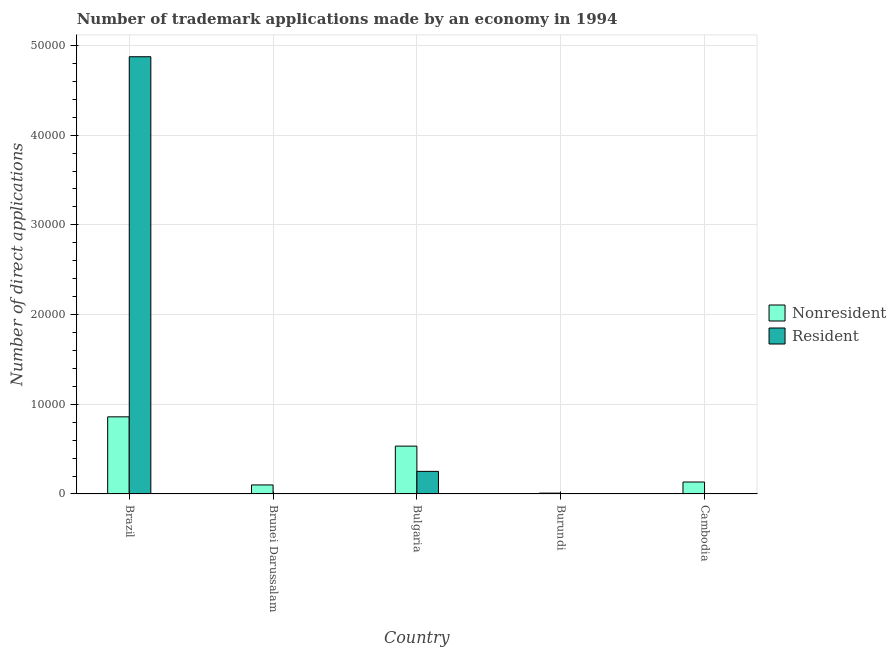What is the label of the 2nd group of bars from the left?
Provide a succinct answer. Brunei Darussalam. In how many cases, is the number of bars for a given country not equal to the number of legend labels?
Make the answer very short. 0. What is the number of trademark applications made by non residents in Brazil?
Offer a terse response. 8599. Across all countries, what is the maximum number of trademark applications made by residents?
Provide a short and direct response. 4.87e+04. Across all countries, what is the minimum number of trademark applications made by non residents?
Your answer should be very brief. 93. In which country was the number of trademark applications made by residents minimum?
Give a very brief answer. Brunei Darussalam. What is the total number of trademark applications made by non residents in the graph?
Offer a very short reply. 1.64e+04. What is the difference between the number of trademark applications made by residents in Brazil and that in Cambodia?
Your answer should be very brief. 4.87e+04. What is the difference between the number of trademark applications made by residents in Cambodia and the number of trademark applications made by non residents in Brazil?
Your response must be concise. -8596. What is the average number of trademark applications made by residents per country?
Your answer should be very brief. 1.03e+04. What is the difference between the number of trademark applications made by non residents and number of trademark applications made by residents in Cambodia?
Offer a terse response. 1331. In how many countries, is the number of trademark applications made by residents greater than 28000 ?
Your response must be concise. 1. What is the ratio of the number of trademark applications made by non residents in Bulgaria to that in Burundi?
Your response must be concise. 57.37. Is the number of trademark applications made by residents in Burundi less than that in Cambodia?
Your response must be concise. No. What is the difference between the highest and the second highest number of trademark applications made by residents?
Your response must be concise. 4.62e+04. What is the difference between the highest and the lowest number of trademark applications made by residents?
Offer a very short reply. 4.87e+04. What does the 1st bar from the left in Brunei Darussalam represents?
Ensure brevity in your answer.  Nonresident. What does the 1st bar from the right in Burundi represents?
Your answer should be very brief. Resident. How many bars are there?
Ensure brevity in your answer.  10. How many countries are there in the graph?
Provide a succinct answer. 5. Are the values on the major ticks of Y-axis written in scientific E-notation?
Offer a terse response. No. Does the graph contain any zero values?
Offer a terse response. No. Does the graph contain grids?
Give a very brief answer. Yes. Where does the legend appear in the graph?
Provide a short and direct response. Center right. How many legend labels are there?
Ensure brevity in your answer.  2. What is the title of the graph?
Keep it short and to the point. Number of trademark applications made by an economy in 1994. Does "Female entrants" appear as one of the legend labels in the graph?
Ensure brevity in your answer.  No. What is the label or title of the Y-axis?
Your answer should be very brief. Number of direct applications. What is the Number of direct applications of Nonresident in Brazil?
Your answer should be very brief. 8599. What is the Number of direct applications in Resident in Brazil?
Give a very brief answer. 4.87e+04. What is the Number of direct applications in Nonresident in Brunei Darussalam?
Your answer should be compact. 1008. What is the Number of direct applications of Resident in Brunei Darussalam?
Ensure brevity in your answer.  3. What is the Number of direct applications of Nonresident in Bulgaria?
Make the answer very short. 5335. What is the Number of direct applications of Resident in Bulgaria?
Your answer should be compact. 2520. What is the Number of direct applications of Nonresident in Burundi?
Provide a succinct answer. 93. What is the Number of direct applications of Nonresident in Cambodia?
Offer a terse response. 1334. Across all countries, what is the maximum Number of direct applications in Nonresident?
Ensure brevity in your answer.  8599. Across all countries, what is the maximum Number of direct applications of Resident?
Provide a succinct answer. 4.87e+04. Across all countries, what is the minimum Number of direct applications of Nonresident?
Provide a short and direct response. 93. Across all countries, what is the minimum Number of direct applications of Resident?
Offer a terse response. 3. What is the total Number of direct applications of Nonresident in the graph?
Your answer should be very brief. 1.64e+04. What is the total Number of direct applications of Resident in the graph?
Ensure brevity in your answer.  5.13e+04. What is the difference between the Number of direct applications in Nonresident in Brazil and that in Brunei Darussalam?
Your answer should be very brief. 7591. What is the difference between the Number of direct applications of Resident in Brazil and that in Brunei Darussalam?
Your response must be concise. 4.87e+04. What is the difference between the Number of direct applications in Nonresident in Brazil and that in Bulgaria?
Make the answer very short. 3264. What is the difference between the Number of direct applications of Resident in Brazil and that in Bulgaria?
Your response must be concise. 4.62e+04. What is the difference between the Number of direct applications in Nonresident in Brazil and that in Burundi?
Your answer should be very brief. 8506. What is the difference between the Number of direct applications in Resident in Brazil and that in Burundi?
Your response must be concise. 4.87e+04. What is the difference between the Number of direct applications of Nonresident in Brazil and that in Cambodia?
Your response must be concise. 7265. What is the difference between the Number of direct applications of Resident in Brazil and that in Cambodia?
Provide a succinct answer. 4.87e+04. What is the difference between the Number of direct applications of Nonresident in Brunei Darussalam and that in Bulgaria?
Your response must be concise. -4327. What is the difference between the Number of direct applications of Resident in Brunei Darussalam and that in Bulgaria?
Make the answer very short. -2517. What is the difference between the Number of direct applications in Nonresident in Brunei Darussalam and that in Burundi?
Provide a succinct answer. 915. What is the difference between the Number of direct applications of Nonresident in Brunei Darussalam and that in Cambodia?
Offer a very short reply. -326. What is the difference between the Number of direct applications of Nonresident in Bulgaria and that in Burundi?
Give a very brief answer. 5242. What is the difference between the Number of direct applications in Resident in Bulgaria and that in Burundi?
Give a very brief answer. 2513. What is the difference between the Number of direct applications of Nonresident in Bulgaria and that in Cambodia?
Give a very brief answer. 4001. What is the difference between the Number of direct applications of Resident in Bulgaria and that in Cambodia?
Your answer should be very brief. 2517. What is the difference between the Number of direct applications in Nonresident in Burundi and that in Cambodia?
Give a very brief answer. -1241. What is the difference between the Number of direct applications in Nonresident in Brazil and the Number of direct applications in Resident in Brunei Darussalam?
Provide a short and direct response. 8596. What is the difference between the Number of direct applications in Nonresident in Brazil and the Number of direct applications in Resident in Bulgaria?
Provide a succinct answer. 6079. What is the difference between the Number of direct applications of Nonresident in Brazil and the Number of direct applications of Resident in Burundi?
Your answer should be compact. 8592. What is the difference between the Number of direct applications in Nonresident in Brazil and the Number of direct applications in Resident in Cambodia?
Your response must be concise. 8596. What is the difference between the Number of direct applications in Nonresident in Brunei Darussalam and the Number of direct applications in Resident in Bulgaria?
Your answer should be very brief. -1512. What is the difference between the Number of direct applications in Nonresident in Brunei Darussalam and the Number of direct applications in Resident in Burundi?
Your response must be concise. 1001. What is the difference between the Number of direct applications of Nonresident in Brunei Darussalam and the Number of direct applications of Resident in Cambodia?
Your response must be concise. 1005. What is the difference between the Number of direct applications of Nonresident in Bulgaria and the Number of direct applications of Resident in Burundi?
Make the answer very short. 5328. What is the difference between the Number of direct applications in Nonresident in Bulgaria and the Number of direct applications in Resident in Cambodia?
Keep it short and to the point. 5332. What is the difference between the Number of direct applications of Nonresident in Burundi and the Number of direct applications of Resident in Cambodia?
Make the answer very short. 90. What is the average Number of direct applications in Nonresident per country?
Provide a succinct answer. 3273.8. What is the average Number of direct applications of Resident per country?
Ensure brevity in your answer.  1.03e+04. What is the difference between the Number of direct applications in Nonresident and Number of direct applications in Resident in Brazil?
Make the answer very short. -4.01e+04. What is the difference between the Number of direct applications of Nonresident and Number of direct applications of Resident in Brunei Darussalam?
Provide a succinct answer. 1005. What is the difference between the Number of direct applications of Nonresident and Number of direct applications of Resident in Bulgaria?
Provide a short and direct response. 2815. What is the difference between the Number of direct applications in Nonresident and Number of direct applications in Resident in Cambodia?
Keep it short and to the point. 1331. What is the ratio of the Number of direct applications of Nonresident in Brazil to that in Brunei Darussalam?
Your response must be concise. 8.53. What is the ratio of the Number of direct applications in Resident in Brazil to that in Brunei Darussalam?
Your response must be concise. 1.62e+04. What is the ratio of the Number of direct applications of Nonresident in Brazil to that in Bulgaria?
Keep it short and to the point. 1.61. What is the ratio of the Number of direct applications of Resident in Brazil to that in Bulgaria?
Offer a terse response. 19.34. What is the ratio of the Number of direct applications of Nonresident in Brazil to that in Burundi?
Ensure brevity in your answer.  92.46. What is the ratio of the Number of direct applications of Resident in Brazil to that in Burundi?
Your answer should be very brief. 6963.14. What is the ratio of the Number of direct applications of Nonresident in Brazil to that in Cambodia?
Offer a terse response. 6.45. What is the ratio of the Number of direct applications in Resident in Brazil to that in Cambodia?
Provide a short and direct response. 1.62e+04. What is the ratio of the Number of direct applications of Nonresident in Brunei Darussalam to that in Bulgaria?
Make the answer very short. 0.19. What is the ratio of the Number of direct applications in Resident in Brunei Darussalam to that in Bulgaria?
Give a very brief answer. 0. What is the ratio of the Number of direct applications of Nonresident in Brunei Darussalam to that in Burundi?
Your answer should be compact. 10.84. What is the ratio of the Number of direct applications of Resident in Brunei Darussalam to that in Burundi?
Your answer should be very brief. 0.43. What is the ratio of the Number of direct applications in Nonresident in Brunei Darussalam to that in Cambodia?
Ensure brevity in your answer.  0.76. What is the ratio of the Number of direct applications of Resident in Brunei Darussalam to that in Cambodia?
Your answer should be very brief. 1. What is the ratio of the Number of direct applications of Nonresident in Bulgaria to that in Burundi?
Make the answer very short. 57.37. What is the ratio of the Number of direct applications of Resident in Bulgaria to that in Burundi?
Keep it short and to the point. 360. What is the ratio of the Number of direct applications of Nonresident in Bulgaria to that in Cambodia?
Your answer should be very brief. 4. What is the ratio of the Number of direct applications of Resident in Bulgaria to that in Cambodia?
Provide a short and direct response. 840. What is the ratio of the Number of direct applications of Nonresident in Burundi to that in Cambodia?
Provide a succinct answer. 0.07. What is the ratio of the Number of direct applications in Resident in Burundi to that in Cambodia?
Your response must be concise. 2.33. What is the difference between the highest and the second highest Number of direct applications in Nonresident?
Ensure brevity in your answer.  3264. What is the difference between the highest and the second highest Number of direct applications of Resident?
Provide a succinct answer. 4.62e+04. What is the difference between the highest and the lowest Number of direct applications of Nonresident?
Your response must be concise. 8506. What is the difference between the highest and the lowest Number of direct applications in Resident?
Make the answer very short. 4.87e+04. 